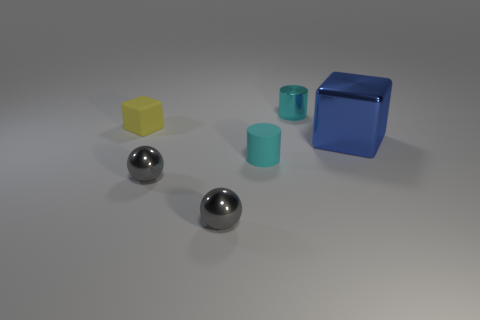There is a large blue thing in front of the tiny cylinder that is behind the cube on the right side of the tiny matte block; what shape is it?
Ensure brevity in your answer.  Cube. What number of spheres are small rubber things or tiny gray objects?
Offer a very short reply. 2. Is there a matte object behind the cube that is to the left of the big shiny object?
Offer a very short reply. No. Do the blue metal object and the yellow object that is in front of the cyan shiny cylinder have the same shape?
Ensure brevity in your answer.  Yes. What number of other things are the same size as the shiny cylinder?
Provide a succinct answer. 4. What number of red objects are small balls or big shiny blocks?
Offer a very short reply. 0. How many blocks are right of the matte cylinder and on the left side of the large cube?
Your response must be concise. 0. The tiny cylinder that is behind the small cylinder that is in front of the tiny cylinder behind the big shiny thing is made of what material?
Your response must be concise. Metal. How many small cyan cylinders are the same material as the small yellow cube?
Make the answer very short. 1. What is the shape of the rubber object that is the same color as the shiny cylinder?
Make the answer very short. Cylinder. 